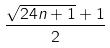<formula> <loc_0><loc_0><loc_500><loc_500>\frac { \sqrt { 2 4 n + 1 } + 1 } { 2 }</formula> 